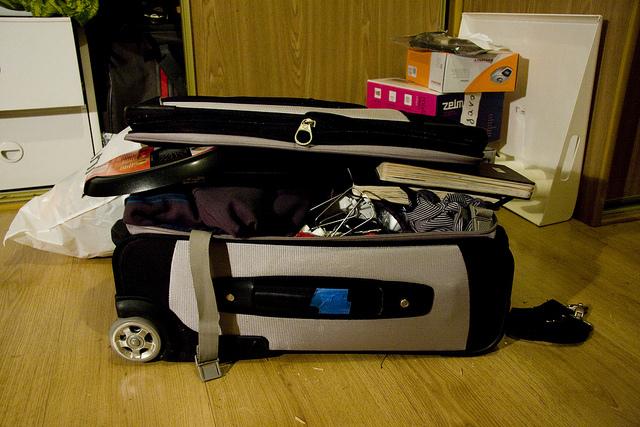What is the purpose of the bow tie on the suitcase?
Quick response, please. Decoration. Is this piece of luggage filled with clutter?
Be succinct. Yes. Is the suitcase on a bed?
Concise answer only. No. Where is the camera?
Write a very short answer. In front of suitcase. What color is this suitcase?
Be succinct. Black and gray. What items are in the left side of the suitcase?
Write a very short answer. Bag. How many pieces of luggage are there?
Give a very brief answer. 1. Is the suitcase closed?
Short answer required. No. What color is the suitcase?
Concise answer only. Gray. 